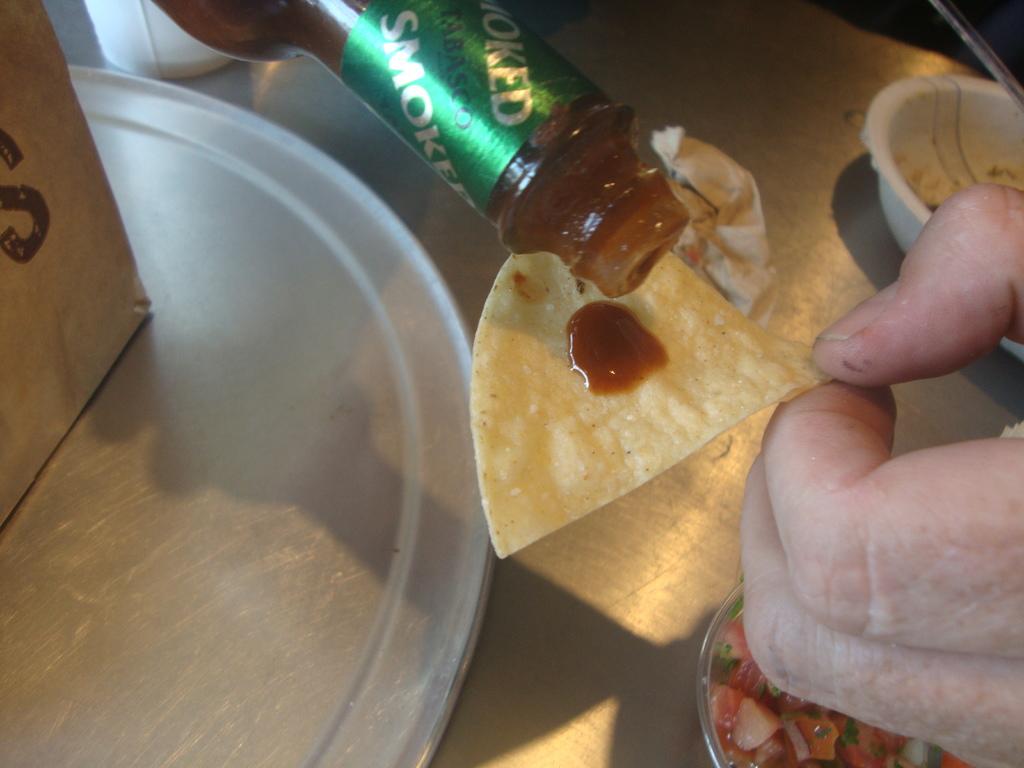What kind of sauce is this?
Make the answer very short. Tabasco. 